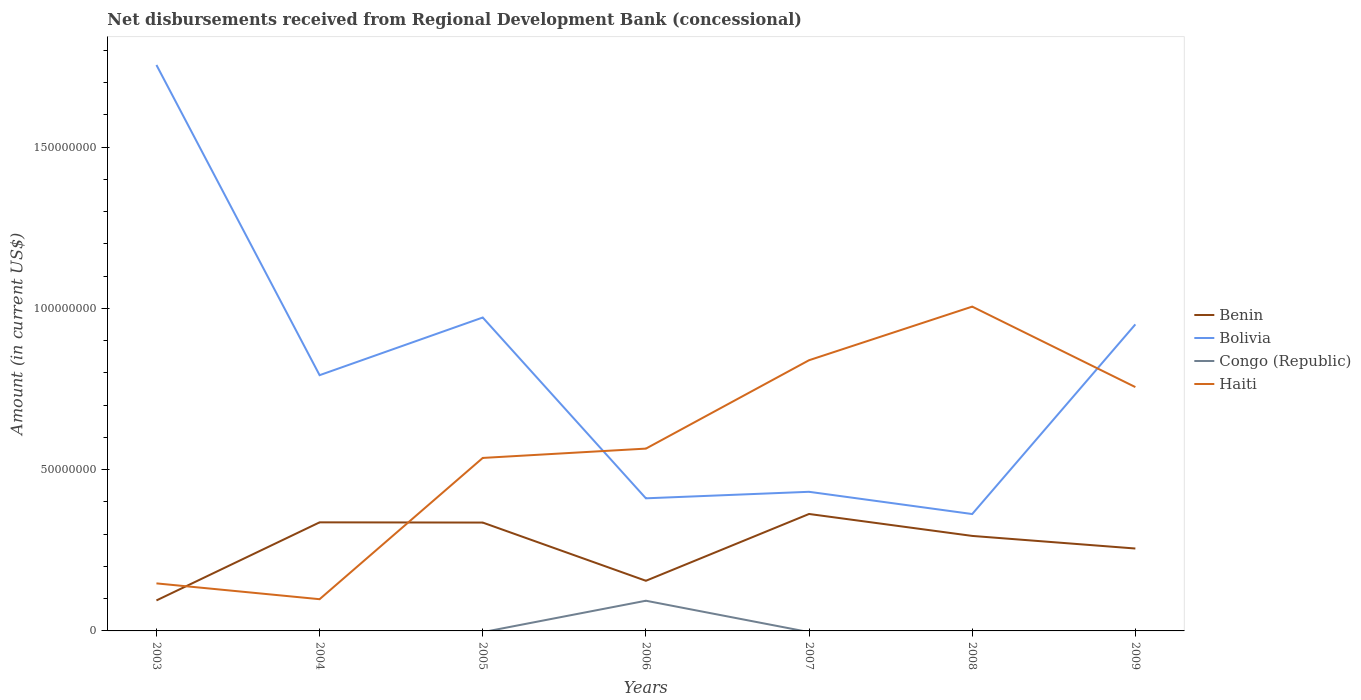Does the line corresponding to Benin intersect with the line corresponding to Haiti?
Provide a short and direct response. Yes. Is the number of lines equal to the number of legend labels?
Offer a terse response. No. Across all years, what is the maximum amount of disbursements received from Regional Development Bank in Bolivia?
Your response must be concise. 3.62e+07. What is the total amount of disbursements received from Regional Development Bank in Bolivia in the graph?
Offer a very short reply. 3.82e+07. What is the difference between the highest and the second highest amount of disbursements received from Regional Development Bank in Haiti?
Your answer should be very brief. 9.07e+07. What is the difference between the highest and the lowest amount of disbursements received from Regional Development Bank in Benin?
Provide a succinct answer. 4. Is the amount of disbursements received from Regional Development Bank in Bolivia strictly greater than the amount of disbursements received from Regional Development Bank in Congo (Republic) over the years?
Your answer should be very brief. No. How many lines are there?
Provide a succinct answer. 4. How many years are there in the graph?
Keep it short and to the point. 7. What is the difference between two consecutive major ticks on the Y-axis?
Provide a short and direct response. 5.00e+07. Does the graph contain grids?
Offer a terse response. No. Where does the legend appear in the graph?
Your response must be concise. Center right. What is the title of the graph?
Keep it short and to the point. Net disbursements received from Regional Development Bank (concessional). Does "Lebanon" appear as one of the legend labels in the graph?
Provide a short and direct response. No. What is the Amount (in current US$) in Benin in 2003?
Ensure brevity in your answer.  9.45e+06. What is the Amount (in current US$) of Bolivia in 2003?
Provide a succinct answer. 1.75e+08. What is the Amount (in current US$) in Haiti in 2003?
Your answer should be very brief. 1.47e+07. What is the Amount (in current US$) of Benin in 2004?
Offer a terse response. 3.37e+07. What is the Amount (in current US$) in Bolivia in 2004?
Give a very brief answer. 7.93e+07. What is the Amount (in current US$) of Haiti in 2004?
Offer a terse response. 9.84e+06. What is the Amount (in current US$) of Benin in 2005?
Your answer should be compact. 3.36e+07. What is the Amount (in current US$) in Bolivia in 2005?
Provide a short and direct response. 9.72e+07. What is the Amount (in current US$) in Haiti in 2005?
Provide a succinct answer. 5.36e+07. What is the Amount (in current US$) in Benin in 2006?
Your answer should be compact. 1.55e+07. What is the Amount (in current US$) in Bolivia in 2006?
Make the answer very short. 4.11e+07. What is the Amount (in current US$) in Congo (Republic) in 2006?
Make the answer very short. 9.36e+06. What is the Amount (in current US$) of Haiti in 2006?
Offer a terse response. 5.65e+07. What is the Amount (in current US$) in Benin in 2007?
Offer a terse response. 3.63e+07. What is the Amount (in current US$) of Bolivia in 2007?
Your response must be concise. 4.31e+07. What is the Amount (in current US$) in Haiti in 2007?
Keep it short and to the point. 8.39e+07. What is the Amount (in current US$) of Benin in 2008?
Provide a short and direct response. 2.95e+07. What is the Amount (in current US$) of Bolivia in 2008?
Your response must be concise. 3.62e+07. What is the Amount (in current US$) of Congo (Republic) in 2008?
Your answer should be very brief. 0. What is the Amount (in current US$) of Haiti in 2008?
Your answer should be compact. 1.01e+08. What is the Amount (in current US$) of Benin in 2009?
Your answer should be very brief. 2.55e+07. What is the Amount (in current US$) of Bolivia in 2009?
Ensure brevity in your answer.  9.50e+07. What is the Amount (in current US$) in Haiti in 2009?
Offer a very short reply. 7.56e+07. Across all years, what is the maximum Amount (in current US$) of Benin?
Make the answer very short. 3.63e+07. Across all years, what is the maximum Amount (in current US$) in Bolivia?
Ensure brevity in your answer.  1.75e+08. Across all years, what is the maximum Amount (in current US$) of Congo (Republic)?
Ensure brevity in your answer.  9.36e+06. Across all years, what is the maximum Amount (in current US$) in Haiti?
Provide a succinct answer. 1.01e+08. Across all years, what is the minimum Amount (in current US$) in Benin?
Make the answer very short. 9.45e+06. Across all years, what is the minimum Amount (in current US$) of Bolivia?
Give a very brief answer. 3.62e+07. Across all years, what is the minimum Amount (in current US$) in Congo (Republic)?
Offer a very short reply. 0. Across all years, what is the minimum Amount (in current US$) of Haiti?
Make the answer very short. 9.84e+06. What is the total Amount (in current US$) in Benin in the graph?
Keep it short and to the point. 1.84e+08. What is the total Amount (in current US$) in Bolivia in the graph?
Keep it short and to the point. 5.67e+08. What is the total Amount (in current US$) of Congo (Republic) in the graph?
Ensure brevity in your answer.  9.36e+06. What is the total Amount (in current US$) of Haiti in the graph?
Provide a short and direct response. 3.95e+08. What is the difference between the Amount (in current US$) of Benin in 2003 and that in 2004?
Give a very brief answer. -2.42e+07. What is the difference between the Amount (in current US$) in Bolivia in 2003 and that in 2004?
Ensure brevity in your answer.  9.62e+07. What is the difference between the Amount (in current US$) in Haiti in 2003 and that in 2004?
Provide a succinct answer. 4.90e+06. What is the difference between the Amount (in current US$) of Benin in 2003 and that in 2005?
Give a very brief answer. -2.41e+07. What is the difference between the Amount (in current US$) of Bolivia in 2003 and that in 2005?
Offer a terse response. 7.83e+07. What is the difference between the Amount (in current US$) in Haiti in 2003 and that in 2005?
Provide a short and direct response. -3.89e+07. What is the difference between the Amount (in current US$) in Benin in 2003 and that in 2006?
Give a very brief answer. -6.09e+06. What is the difference between the Amount (in current US$) of Bolivia in 2003 and that in 2006?
Offer a very short reply. 1.34e+08. What is the difference between the Amount (in current US$) of Haiti in 2003 and that in 2006?
Keep it short and to the point. -4.18e+07. What is the difference between the Amount (in current US$) in Benin in 2003 and that in 2007?
Keep it short and to the point. -2.68e+07. What is the difference between the Amount (in current US$) in Bolivia in 2003 and that in 2007?
Your answer should be compact. 1.32e+08. What is the difference between the Amount (in current US$) of Haiti in 2003 and that in 2007?
Your response must be concise. -6.92e+07. What is the difference between the Amount (in current US$) of Benin in 2003 and that in 2008?
Keep it short and to the point. -2.00e+07. What is the difference between the Amount (in current US$) of Bolivia in 2003 and that in 2008?
Your answer should be very brief. 1.39e+08. What is the difference between the Amount (in current US$) of Haiti in 2003 and that in 2008?
Offer a very short reply. -8.58e+07. What is the difference between the Amount (in current US$) in Benin in 2003 and that in 2009?
Your answer should be compact. -1.61e+07. What is the difference between the Amount (in current US$) of Bolivia in 2003 and that in 2009?
Offer a terse response. 8.04e+07. What is the difference between the Amount (in current US$) in Haiti in 2003 and that in 2009?
Give a very brief answer. -6.09e+07. What is the difference between the Amount (in current US$) of Benin in 2004 and that in 2005?
Provide a succinct answer. 6.90e+04. What is the difference between the Amount (in current US$) of Bolivia in 2004 and that in 2005?
Give a very brief answer. -1.79e+07. What is the difference between the Amount (in current US$) in Haiti in 2004 and that in 2005?
Your response must be concise. -4.38e+07. What is the difference between the Amount (in current US$) of Benin in 2004 and that in 2006?
Provide a short and direct response. 1.81e+07. What is the difference between the Amount (in current US$) in Bolivia in 2004 and that in 2006?
Keep it short and to the point. 3.82e+07. What is the difference between the Amount (in current US$) in Haiti in 2004 and that in 2006?
Provide a short and direct response. -4.67e+07. What is the difference between the Amount (in current US$) of Benin in 2004 and that in 2007?
Your response must be concise. -2.60e+06. What is the difference between the Amount (in current US$) in Bolivia in 2004 and that in 2007?
Your answer should be very brief. 3.62e+07. What is the difference between the Amount (in current US$) of Haiti in 2004 and that in 2007?
Offer a very short reply. -7.41e+07. What is the difference between the Amount (in current US$) in Benin in 2004 and that in 2008?
Keep it short and to the point. 4.21e+06. What is the difference between the Amount (in current US$) in Bolivia in 2004 and that in 2008?
Provide a succinct answer. 4.30e+07. What is the difference between the Amount (in current US$) in Haiti in 2004 and that in 2008?
Ensure brevity in your answer.  -9.07e+07. What is the difference between the Amount (in current US$) of Benin in 2004 and that in 2009?
Your response must be concise. 8.11e+06. What is the difference between the Amount (in current US$) in Bolivia in 2004 and that in 2009?
Your response must be concise. -1.58e+07. What is the difference between the Amount (in current US$) in Haiti in 2004 and that in 2009?
Your answer should be very brief. -6.58e+07. What is the difference between the Amount (in current US$) in Benin in 2005 and that in 2006?
Provide a succinct answer. 1.80e+07. What is the difference between the Amount (in current US$) of Bolivia in 2005 and that in 2006?
Provide a short and direct response. 5.61e+07. What is the difference between the Amount (in current US$) of Haiti in 2005 and that in 2006?
Your response must be concise. -2.89e+06. What is the difference between the Amount (in current US$) in Benin in 2005 and that in 2007?
Your response must be concise. -2.66e+06. What is the difference between the Amount (in current US$) of Bolivia in 2005 and that in 2007?
Your response must be concise. 5.40e+07. What is the difference between the Amount (in current US$) of Haiti in 2005 and that in 2007?
Offer a terse response. -3.03e+07. What is the difference between the Amount (in current US$) of Benin in 2005 and that in 2008?
Your answer should be compact. 4.14e+06. What is the difference between the Amount (in current US$) in Bolivia in 2005 and that in 2008?
Offer a terse response. 6.09e+07. What is the difference between the Amount (in current US$) in Haiti in 2005 and that in 2008?
Your response must be concise. -4.69e+07. What is the difference between the Amount (in current US$) in Benin in 2005 and that in 2009?
Your answer should be compact. 8.04e+06. What is the difference between the Amount (in current US$) of Bolivia in 2005 and that in 2009?
Your answer should be compact. 2.13e+06. What is the difference between the Amount (in current US$) of Haiti in 2005 and that in 2009?
Give a very brief answer. -2.20e+07. What is the difference between the Amount (in current US$) in Benin in 2006 and that in 2007?
Provide a short and direct response. -2.07e+07. What is the difference between the Amount (in current US$) of Bolivia in 2006 and that in 2007?
Your answer should be compact. -2.02e+06. What is the difference between the Amount (in current US$) in Haiti in 2006 and that in 2007?
Make the answer very short. -2.74e+07. What is the difference between the Amount (in current US$) in Benin in 2006 and that in 2008?
Provide a short and direct response. -1.39e+07. What is the difference between the Amount (in current US$) of Bolivia in 2006 and that in 2008?
Provide a short and direct response. 4.87e+06. What is the difference between the Amount (in current US$) of Haiti in 2006 and that in 2008?
Your response must be concise. -4.40e+07. What is the difference between the Amount (in current US$) of Benin in 2006 and that in 2009?
Your answer should be compact. -1.00e+07. What is the difference between the Amount (in current US$) of Bolivia in 2006 and that in 2009?
Your answer should be very brief. -5.39e+07. What is the difference between the Amount (in current US$) of Haiti in 2006 and that in 2009?
Your answer should be very brief. -1.91e+07. What is the difference between the Amount (in current US$) in Benin in 2007 and that in 2008?
Provide a succinct answer. 6.80e+06. What is the difference between the Amount (in current US$) in Bolivia in 2007 and that in 2008?
Your answer should be very brief. 6.89e+06. What is the difference between the Amount (in current US$) in Haiti in 2007 and that in 2008?
Give a very brief answer. -1.66e+07. What is the difference between the Amount (in current US$) of Benin in 2007 and that in 2009?
Your answer should be compact. 1.07e+07. What is the difference between the Amount (in current US$) in Bolivia in 2007 and that in 2009?
Your response must be concise. -5.19e+07. What is the difference between the Amount (in current US$) in Haiti in 2007 and that in 2009?
Provide a short and direct response. 8.33e+06. What is the difference between the Amount (in current US$) of Benin in 2008 and that in 2009?
Provide a succinct answer. 3.90e+06. What is the difference between the Amount (in current US$) of Bolivia in 2008 and that in 2009?
Your answer should be compact. -5.88e+07. What is the difference between the Amount (in current US$) in Haiti in 2008 and that in 2009?
Provide a short and direct response. 2.50e+07. What is the difference between the Amount (in current US$) of Benin in 2003 and the Amount (in current US$) of Bolivia in 2004?
Provide a short and direct response. -6.98e+07. What is the difference between the Amount (in current US$) of Benin in 2003 and the Amount (in current US$) of Haiti in 2004?
Ensure brevity in your answer.  -3.83e+05. What is the difference between the Amount (in current US$) of Bolivia in 2003 and the Amount (in current US$) of Haiti in 2004?
Offer a very short reply. 1.66e+08. What is the difference between the Amount (in current US$) in Benin in 2003 and the Amount (in current US$) in Bolivia in 2005?
Offer a terse response. -8.77e+07. What is the difference between the Amount (in current US$) in Benin in 2003 and the Amount (in current US$) in Haiti in 2005?
Offer a very short reply. -4.42e+07. What is the difference between the Amount (in current US$) in Bolivia in 2003 and the Amount (in current US$) in Haiti in 2005?
Your answer should be compact. 1.22e+08. What is the difference between the Amount (in current US$) in Benin in 2003 and the Amount (in current US$) in Bolivia in 2006?
Your response must be concise. -3.17e+07. What is the difference between the Amount (in current US$) of Benin in 2003 and the Amount (in current US$) of Congo (Republic) in 2006?
Your response must be concise. 9.20e+04. What is the difference between the Amount (in current US$) in Benin in 2003 and the Amount (in current US$) in Haiti in 2006?
Offer a terse response. -4.71e+07. What is the difference between the Amount (in current US$) of Bolivia in 2003 and the Amount (in current US$) of Congo (Republic) in 2006?
Provide a short and direct response. 1.66e+08. What is the difference between the Amount (in current US$) in Bolivia in 2003 and the Amount (in current US$) in Haiti in 2006?
Keep it short and to the point. 1.19e+08. What is the difference between the Amount (in current US$) in Benin in 2003 and the Amount (in current US$) in Bolivia in 2007?
Keep it short and to the point. -3.37e+07. What is the difference between the Amount (in current US$) in Benin in 2003 and the Amount (in current US$) in Haiti in 2007?
Your response must be concise. -7.45e+07. What is the difference between the Amount (in current US$) of Bolivia in 2003 and the Amount (in current US$) of Haiti in 2007?
Offer a very short reply. 9.15e+07. What is the difference between the Amount (in current US$) of Benin in 2003 and the Amount (in current US$) of Bolivia in 2008?
Provide a short and direct response. -2.68e+07. What is the difference between the Amount (in current US$) of Benin in 2003 and the Amount (in current US$) of Haiti in 2008?
Make the answer very short. -9.11e+07. What is the difference between the Amount (in current US$) in Bolivia in 2003 and the Amount (in current US$) in Haiti in 2008?
Your answer should be very brief. 7.49e+07. What is the difference between the Amount (in current US$) of Benin in 2003 and the Amount (in current US$) of Bolivia in 2009?
Ensure brevity in your answer.  -8.56e+07. What is the difference between the Amount (in current US$) in Benin in 2003 and the Amount (in current US$) in Haiti in 2009?
Give a very brief answer. -6.61e+07. What is the difference between the Amount (in current US$) of Bolivia in 2003 and the Amount (in current US$) of Haiti in 2009?
Provide a succinct answer. 9.99e+07. What is the difference between the Amount (in current US$) of Benin in 2004 and the Amount (in current US$) of Bolivia in 2005?
Keep it short and to the point. -6.35e+07. What is the difference between the Amount (in current US$) in Benin in 2004 and the Amount (in current US$) in Haiti in 2005?
Keep it short and to the point. -2.00e+07. What is the difference between the Amount (in current US$) of Bolivia in 2004 and the Amount (in current US$) of Haiti in 2005?
Make the answer very short. 2.57e+07. What is the difference between the Amount (in current US$) in Benin in 2004 and the Amount (in current US$) in Bolivia in 2006?
Give a very brief answer. -7.45e+06. What is the difference between the Amount (in current US$) in Benin in 2004 and the Amount (in current US$) in Congo (Republic) in 2006?
Offer a very short reply. 2.43e+07. What is the difference between the Amount (in current US$) of Benin in 2004 and the Amount (in current US$) of Haiti in 2006?
Provide a short and direct response. -2.29e+07. What is the difference between the Amount (in current US$) in Bolivia in 2004 and the Amount (in current US$) in Congo (Republic) in 2006?
Your answer should be compact. 6.99e+07. What is the difference between the Amount (in current US$) of Bolivia in 2004 and the Amount (in current US$) of Haiti in 2006?
Provide a succinct answer. 2.28e+07. What is the difference between the Amount (in current US$) of Benin in 2004 and the Amount (in current US$) of Bolivia in 2007?
Give a very brief answer. -9.47e+06. What is the difference between the Amount (in current US$) of Benin in 2004 and the Amount (in current US$) of Haiti in 2007?
Provide a short and direct response. -5.03e+07. What is the difference between the Amount (in current US$) in Bolivia in 2004 and the Amount (in current US$) in Haiti in 2007?
Make the answer very short. -4.64e+06. What is the difference between the Amount (in current US$) of Benin in 2004 and the Amount (in current US$) of Bolivia in 2008?
Ensure brevity in your answer.  -2.58e+06. What is the difference between the Amount (in current US$) in Benin in 2004 and the Amount (in current US$) in Haiti in 2008?
Make the answer very short. -6.69e+07. What is the difference between the Amount (in current US$) of Bolivia in 2004 and the Amount (in current US$) of Haiti in 2008?
Give a very brief answer. -2.13e+07. What is the difference between the Amount (in current US$) of Benin in 2004 and the Amount (in current US$) of Bolivia in 2009?
Make the answer very short. -6.14e+07. What is the difference between the Amount (in current US$) of Benin in 2004 and the Amount (in current US$) of Haiti in 2009?
Your response must be concise. -4.19e+07. What is the difference between the Amount (in current US$) of Bolivia in 2004 and the Amount (in current US$) of Haiti in 2009?
Offer a terse response. 3.69e+06. What is the difference between the Amount (in current US$) in Benin in 2005 and the Amount (in current US$) in Bolivia in 2006?
Your answer should be compact. -7.52e+06. What is the difference between the Amount (in current US$) of Benin in 2005 and the Amount (in current US$) of Congo (Republic) in 2006?
Keep it short and to the point. 2.42e+07. What is the difference between the Amount (in current US$) of Benin in 2005 and the Amount (in current US$) of Haiti in 2006?
Your answer should be compact. -2.29e+07. What is the difference between the Amount (in current US$) in Bolivia in 2005 and the Amount (in current US$) in Congo (Republic) in 2006?
Offer a terse response. 8.78e+07. What is the difference between the Amount (in current US$) of Bolivia in 2005 and the Amount (in current US$) of Haiti in 2006?
Offer a very short reply. 4.06e+07. What is the difference between the Amount (in current US$) of Benin in 2005 and the Amount (in current US$) of Bolivia in 2007?
Your response must be concise. -9.54e+06. What is the difference between the Amount (in current US$) of Benin in 2005 and the Amount (in current US$) of Haiti in 2007?
Keep it short and to the point. -5.03e+07. What is the difference between the Amount (in current US$) in Bolivia in 2005 and the Amount (in current US$) in Haiti in 2007?
Offer a very short reply. 1.32e+07. What is the difference between the Amount (in current US$) of Benin in 2005 and the Amount (in current US$) of Bolivia in 2008?
Provide a short and direct response. -2.64e+06. What is the difference between the Amount (in current US$) of Benin in 2005 and the Amount (in current US$) of Haiti in 2008?
Your answer should be very brief. -6.69e+07. What is the difference between the Amount (in current US$) of Bolivia in 2005 and the Amount (in current US$) of Haiti in 2008?
Your response must be concise. -3.38e+06. What is the difference between the Amount (in current US$) in Benin in 2005 and the Amount (in current US$) in Bolivia in 2009?
Provide a short and direct response. -6.14e+07. What is the difference between the Amount (in current US$) of Benin in 2005 and the Amount (in current US$) of Haiti in 2009?
Make the answer very short. -4.20e+07. What is the difference between the Amount (in current US$) of Bolivia in 2005 and the Amount (in current US$) of Haiti in 2009?
Offer a terse response. 2.16e+07. What is the difference between the Amount (in current US$) in Benin in 2006 and the Amount (in current US$) in Bolivia in 2007?
Make the answer very short. -2.76e+07. What is the difference between the Amount (in current US$) of Benin in 2006 and the Amount (in current US$) of Haiti in 2007?
Provide a succinct answer. -6.84e+07. What is the difference between the Amount (in current US$) in Bolivia in 2006 and the Amount (in current US$) in Haiti in 2007?
Give a very brief answer. -4.28e+07. What is the difference between the Amount (in current US$) in Congo (Republic) in 2006 and the Amount (in current US$) in Haiti in 2007?
Provide a short and direct response. -7.46e+07. What is the difference between the Amount (in current US$) of Benin in 2006 and the Amount (in current US$) of Bolivia in 2008?
Give a very brief answer. -2.07e+07. What is the difference between the Amount (in current US$) in Benin in 2006 and the Amount (in current US$) in Haiti in 2008?
Offer a very short reply. -8.50e+07. What is the difference between the Amount (in current US$) in Bolivia in 2006 and the Amount (in current US$) in Haiti in 2008?
Ensure brevity in your answer.  -5.94e+07. What is the difference between the Amount (in current US$) in Congo (Republic) in 2006 and the Amount (in current US$) in Haiti in 2008?
Give a very brief answer. -9.12e+07. What is the difference between the Amount (in current US$) in Benin in 2006 and the Amount (in current US$) in Bolivia in 2009?
Your answer should be compact. -7.95e+07. What is the difference between the Amount (in current US$) of Benin in 2006 and the Amount (in current US$) of Haiti in 2009?
Your answer should be compact. -6.00e+07. What is the difference between the Amount (in current US$) in Bolivia in 2006 and the Amount (in current US$) in Haiti in 2009?
Offer a terse response. -3.45e+07. What is the difference between the Amount (in current US$) in Congo (Republic) in 2006 and the Amount (in current US$) in Haiti in 2009?
Provide a succinct answer. -6.62e+07. What is the difference between the Amount (in current US$) in Benin in 2007 and the Amount (in current US$) in Bolivia in 2008?
Your answer should be very brief. 2.00e+04. What is the difference between the Amount (in current US$) of Benin in 2007 and the Amount (in current US$) of Haiti in 2008?
Your response must be concise. -6.43e+07. What is the difference between the Amount (in current US$) of Bolivia in 2007 and the Amount (in current US$) of Haiti in 2008?
Offer a very short reply. -5.74e+07. What is the difference between the Amount (in current US$) in Benin in 2007 and the Amount (in current US$) in Bolivia in 2009?
Provide a succinct answer. -5.88e+07. What is the difference between the Amount (in current US$) in Benin in 2007 and the Amount (in current US$) in Haiti in 2009?
Make the answer very short. -3.93e+07. What is the difference between the Amount (in current US$) of Bolivia in 2007 and the Amount (in current US$) of Haiti in 2009?
Provide a short and direct response. -3.25e+07. What is the difference between the Amount (in current US$) in Benin in 2008 and the Amount (in current US$) in Bolivia in 2009?
Offer a terse response. -6.56e+07. What is the difference between the Amount (in current US$) of Benin in 2008 and the Amount (in current US$) of Haiti in 2009?
Keep it short and to the point. -4.61e+07. What is the difference between the Amount (in current US$) of Bolivia in 2008 and the Amount (in current US$) of Haiti in 2009?
Your answer should be very brief. -3.94e+07. What is the average Amount (in current US$) of Benin per year?
Offer a very short reply. 2.62e+07. What is the average Amount (in current US$) in Bolivia per year?
Your response must be concise. 8.11e+07. What is the average Amount (in current US$) of Congo (Republic) per year?
Offer a very short reply. 1.34e+06. What is the average Amount (in current US$) in Haiti per year?
Provide a succinct answer. 5.64e+07. In the year 2003, what is the difference between the Amount (in current US$) in Benin and Amount (in current US$) in Bolivia?
Offer a very short reply. -1.66e+08. In the year 2003, what is the difference between the Amount (in current US$) in Benin and Amount (in current US$) in Haiti?
Ensure brevity in your answer.  -5.29e+06. In the year 2003, what is the difference between the Amount (in current US$) in Bolivia and Amount (in current US$) in Haiti?
Your answer should be very brief. 1.61e+08. In the year 2004, what is the difference between the Amount (in current US$) in Benin and Amount (in current US$) in Bolivia?
Your answer should be very brief. -4.56e+07. In the year 2004, what is the difference between the Amount (in current US$) of Benin and Amount (in current US$) of Haiti?
Keep it short and to the point. 2.38e+07. In the year 2004, what is the difference between the Amount (in current US$) of Bolivia and Amount (in current US$) of Haiti?
Provide a short and direct response. 6.94e+07. In the year 2005, what is the difference between the Amount (in current US$) in Benin and Amount (in current US$) in Bolivia?
Offer a terse response. -6.36e+07. In the year 2005, what is the difference between the Amount (in current US$) of Benin and Amount (in current US$) of Haiti?
Give a very brief answer. -2.00e+07. In the year 2005, what is the difference between the Amount (in current US$) of Bolivia and Amount (in current US$) of Haiti?
Give a very brief answer. 4.35e+07. In the year 2006, what is the difference between the Amount (in current US$) in Benin and Amount (in current US$) in Bolivia?
Ensure brevity in your answer.  -2.56e+07. In the year 2006, what is the difference between the Amount (in current US$) of Benin and Amount (in current US$) of Congo (Republic)?
Your response must be concise. 6.19e+06. In the year 2006, what is the difference between the Amount (in current US$) of Benin and Amount (in current US$) of Haiti?
Your response must be concise. -4.10e+07. In the year 2006, what is the difference between the Amount (in current US$) in Bolivia and Amount (in current US$) in Congo (Republic)?
Make the answer very short. 3.17e+07. In the year 2006, what is the difference between the Amount (in current US$) in Bolivia and Amount (in current US$) in Haiti?
Give a very brief answer. -1.54e+07. In the year 2006, what is the difference between the Amount (in current US$) in Congo (Republic) and Amount (in current US$) in Haiti?
Provide a succinct answer. -4.72e+07. In the year 2007, what is the difference between the Amount (in current US$) in Benin and Amount (in current US$) in Bolivia?
Keep it short and to the point. -6.87e+06. In the year 2007, what is the difference between the Amount (in current US$) in Benin and Amount (in current US$) in Haiti?
Keep it short and to the point. -4.77e+07. In the year 2007, what is the difference between the Amount (in current US$) of Bolivia and Amount (in current US$) of Haiti?
Offer a very short reply. -4.08e+07. In the year 2008, what is the difference between the Amount (in current US$) in Benin and Amount (in current US$) in Bolivia?
Make the answer very short. -6.78e+06. In the year 2008, what is the difference between the Amount (in current US$) in Benin and Amount (in current US$) in Haiti?
Ensure brevity in your answer.  -7.11e+07. In the year 2008, what is the difference between the Amount (in current US$) in Bolivia and Amount (in current US$) in Haiti?
Offer a very short reply. -6.43e+07. In the year 2009, what is the difference between the Amount (in current US$) of Benin and Amount (in current US$) of Bolivia?
Your answer should be compact. -6.95e+07. In the year 2009, what is the difference between the Amount (in current US$) in Benin and Amount (in current US$) in Haiti?
Your answer should be very brief. -5.00e+07. In the year 2009, what is the difference between the Amount (in current US$) in Bolivia and Amount (in current US$) in Haiti?
Make the answer very short. 1.94e+07. What is the ratio of the Amount (in current US$) in Benin in 2003 to that in 2004?
Provide a succinct answer. 0.28. What is the ratio of the Amount (in current US$) in Bolivia in 2003 to that in 2004?
Provide a succinct answer. 2.21. What is the ratio of the Amount (in current US$) of Haiti in 2003 to that in 2004?
Ensure brevity in your answer.  1.5. What is the ratio of the Amount (in current US$) in Benin in 2003 to that in 2005?
Provide a short and direct response. 0.28. What is the ratio of the Amount (in current US$) of Bolivia in 2003 to that in 2005?
Your answer should be very brief. 1.81. What is the ratio of the Amount (in current US$) in Haiti in 2003 to that in 2005?
Ensure brevity in your answer.  0.27. What is the ratio of the Amount (in current US$) in Benin in 2003 to that in 2006?
Provide a short and direct response. 0.61. What is the ratio of the Amount (in current US$) of Bolivia in 2003 to that in 2006?
Offer a terse response. 4.27. What is the ratio of the Amount (in current US$) in Haiti in 2003 to that in 2006?
Your answer should be compact. 0.26. What is the ratio of the Amount (in current US$) in Benin in 2003 to that in 2007?
Ensure brevity in your answer.  0.26. What is the ratio of the Amount (in current US$) in Bolivia in 2003 to that in 2007?
Give a very brief answer. 4.07. What is the ratio of the Amount (in current US$) of Haiti in 2003 to that in 2007?
Your answer should be compact. 0.18. What is the ratio of the Amount (in current US$) in Benin in 2003 to that in 2008?
Your answer should be very brief. 0.32. What is the ratio of the Amount (in current US$) of Bolivia in 2003 to that in 2008?
Make the answer very short. 4.84. What is the ratio of the Amount (in current US$) in Haiti in 2003 to that in 2008?
Ensure brevity in your answer.  0.15. What is the ratio of the Amount (in current US$) of Benin in 2003 to that in 2009?
Offer a very short reply. 0.37. What is the ratio of the Amount (in current US$) in Bolivia in 2003 to that in 2009?
Provide a short and direct response. 1.85. What is the ratio of the Amount (in current US$) of Haiti in 2003 to that in 2009?
Make the answer very short. 0.2. What is the ratio of the Amount (in current US$) in Benin in 2004 to that in 2005?
Your answer should be compact. 1. What is the ratio of the Amount (in current US$) of Bolivia in 2004 to that in 2005?
Offer a very short reply. 0.82. What is the ratio of the Amount (in current US$) of Haiti in 2004 to that in 2005?
Ensure brevity in your answer.  0.18. What is the ratio of the Amount (in current US$) of Benin in 2004 to that in 2006?
Give a very brief answer. 2.17. What is the ratio of the Amount (in current US$) of Bolivia in 2004 to that in 2006?
Ensure brevity in your answer.  1.93. What is the ratio of the Amount (in current US$) in Haiti in 2004 to that in 2006?
Make the answer very short. 0.17. What is the ratio of the Amount (in current US$) of Benin in 2004 to that in 2007?
Your answer should be very brief. 0.93. What is the ratio of the Amount (in current US$) of Bolivia in 2004 to that in 2007?
Offer a very short reply. 1.84. What is the ratio of the Amount (in current US$) of Haiti in 2004 to that in 2007?
Offer a very short reply. 0.12. What is the ratio of the Amount (in current US$) of Benin in 2004 to that in 2008?
Your answer should be very brief. 1.14. What is the ratio of the Amount (in current US$) in Bolivia in 2004 to that in 2008?
Keep it short and to the point. 2.19. What is the ratio of the Amount (in current US$) in Haiti in 2004 to that in 2008?
Offer a terse response. 0.1. What is the ratio of the Amount (in current US$) of Benin in 2004 to that in 2009?
Ensure brevity in your answer.  1.32. What is the ratio of the Amount (in current US$) of Bolivia in 2004 to that in 2009?
Give a very brief answer. 0.83. What is the ratio of the Amount (in current US$) of Haiti in 2004 to that in 2009?
Your answer should be very brief. 0.13. What is the ratio of the Amount (in current US$) in Benin in 2005 to that in 2006?
Offer a very short reply. 2.16. What is the ratio of the Amount (in current US$) in Bolivia in 2005 to that in 2006?
Offer a very short reply. 2.36. What is the ratio of the Amount (in current US$) of Haiti in 2005 to that in 2006?
Keep it short and to the point. 0.95. What is the ratio of the Amount (in current US$) in Benin in 2005 to that in 2007?
Give a very brief answer. 0.93. What is the ratio of the Amount (in current US$) in Bolivia in 2005 to that in 2007?
Provide a short and direct response. 2.25. What is the ratio of the Amount (in current US$) of Haiti in 2005 to that in 2007?
Provide a succinct answer. 0.64. What is the ratio of the Amount (in current US$) of Benin in 2005 to that in 2008?
Provide a short and direct response. 1.14. What is the ratio of the Amount (in current US$) in Bolivia in 2005 to that in 2008?
Offer a terse response. 2.68. What is the ratio of the Amount (in current US$) of Haiti in 2005 to that in 2008?
Ensure brevity in your answer.  0.53. What is the ratio of the Amount (in current US$) of Benin in 2005 to that in 2009?
Offer a terse response. 1.31. What is the ratio of the Amount (in current US$) of Bolivia in 2005 to that in 2009?
Provide a short and direct response. 1.02. What is the ratio of the Amount (in current US$) of Haiti in 2005 to that in 2009?
Make the answer very short. 0.71. What is the ratio of the Amount (in current US$) in Benin in 2006 to that in 2007?
Keep it short and to the point. 0.43. What is the ratio of the Amount (in current US$) of Bolivia in 2006 to that in 2007?
Provide a succinct answer. 0.95. What is the ratio of the Amount (in current US$) of Haiti in 2006 to that in 2007?
Offer a terse response. 0.67. What is the ratio of the Amount (in current US$) in Benin in 2006 to that in 2008?
Make the answer very short. 0.53. What is the ratio of the Amount (in current US$) in Bolivia in 2006 to that in 2008?
Keep it short and to the point. 1.13. What is the ratio of the Amount (in current US$) in Haiti in 2006 to that in 2008?
Provide a short and direct response. 0.56. What is the ratio of the Amount (in current US$) in Benin in 2006 to that in 2009?
Offer a very short reply. 0.61. What is the ratio of the Amount (in current US$) of Bolivia in 2006 to that in 2009?
Ensure brevity in your answer.  0.43. What is the ratio of the Amount (in current US$) of Haiti in 2006 to that in 2009?
Give a very brief answer. 0.75. What is the ratio of the Amount (in current US$) in Benin in 2007 to that in 2008?
Provide a short and direct response. 1.23. What is the ratio of the Amount (in current US$) of Bolivia in 2007 to that in 2008?
Make the answer very short. 1.19. What is the ratio of the Amount (in current US$) in Haiti in 2007 to that in 2008?
Offer a terse response. 0.83. What is the ratio of the Amount (in current US$) in Benin in 2007 to that in 2009?
Your answer should be very brief. 1.42. What is the ratio of the Amount (in current US$) in Bolivia in 2007 to that in 2009?
Provide a succinct answer. 0.45. What is the ratio of the Amount (in current US$) of Haiti in 2007 to that in 2009?
Your answer should be very brief. 1.11. What is the ratio of the Amount (in current US$) of Benin in 2008 to that in 2009?
Make the answer very short. 1.15. What is the ratio of the Amount (in current US$) in Bolivia in 2008 to that in 2009?
Your answer should be compact. 0.38. What is the ratio of the Amount (in current US$) in Haiti in 2008 to that in 2009?
Offer a very short reply. 1.33. What is the difference between the highest and the second highest Amount (in current US$) of Benin?
Offer a very short reply. 2.60e+06. What is the difference between the highest and the second highest Amount (in current US$) of Bolivia?
Provide a succinct answer. 7.83e+07. What is the difference between the highest and the second highest Amount (in current US$) in Haiti?
Offer a very short reply. 1.66e+07. What is the difference between the highest and the lowest Amount (in current US$) in Benin?
Your response must be concise. 2.68e+07. What is the difference between the highest and the lowest Amount (in current US$) in Bolivia?
Keep it short and to the point. 1.39e+08. What is the difference between the highest and the lowest Amount (in current US$) of Congo (Republic)?
Your response must be concise. 9.36e+06. What is the difference between the highest and the lowest Amount (in current US$) in Haiti?
Your answer should be very brief. 9.07e+07. 